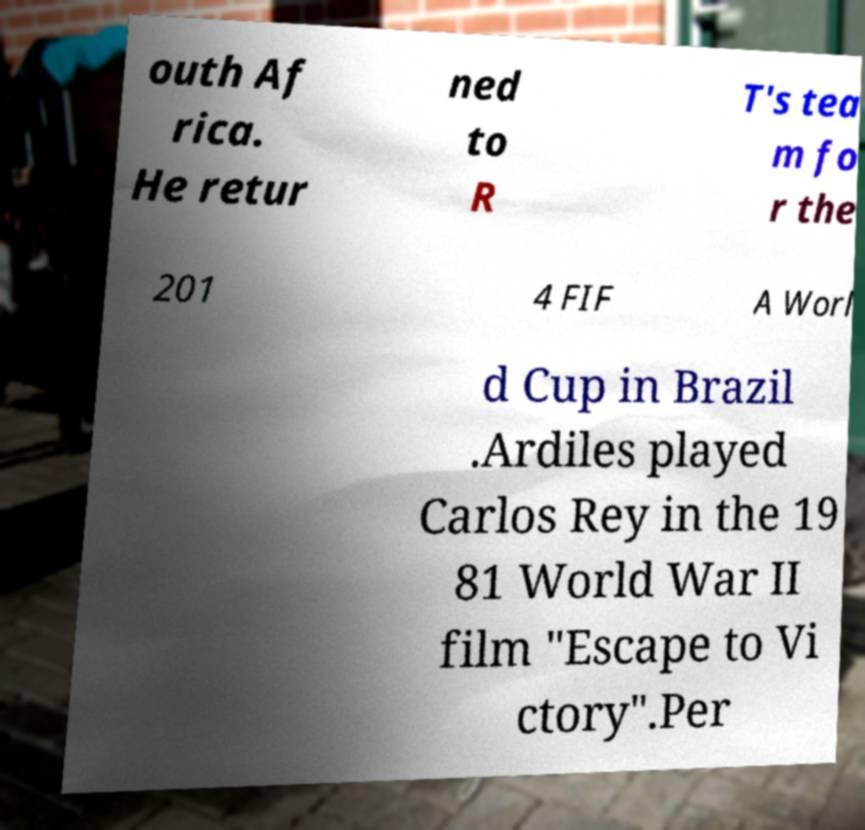Can you accurately transcribe the text from the provided image for me? outh Af rica. He retur ned to R T's tea m fo r the 201 4 FIF A Worl d Cup in Brazil .Ardiles played Carlos Rey in the 19 81 World War II film "Escape to Vi ctory".Per 